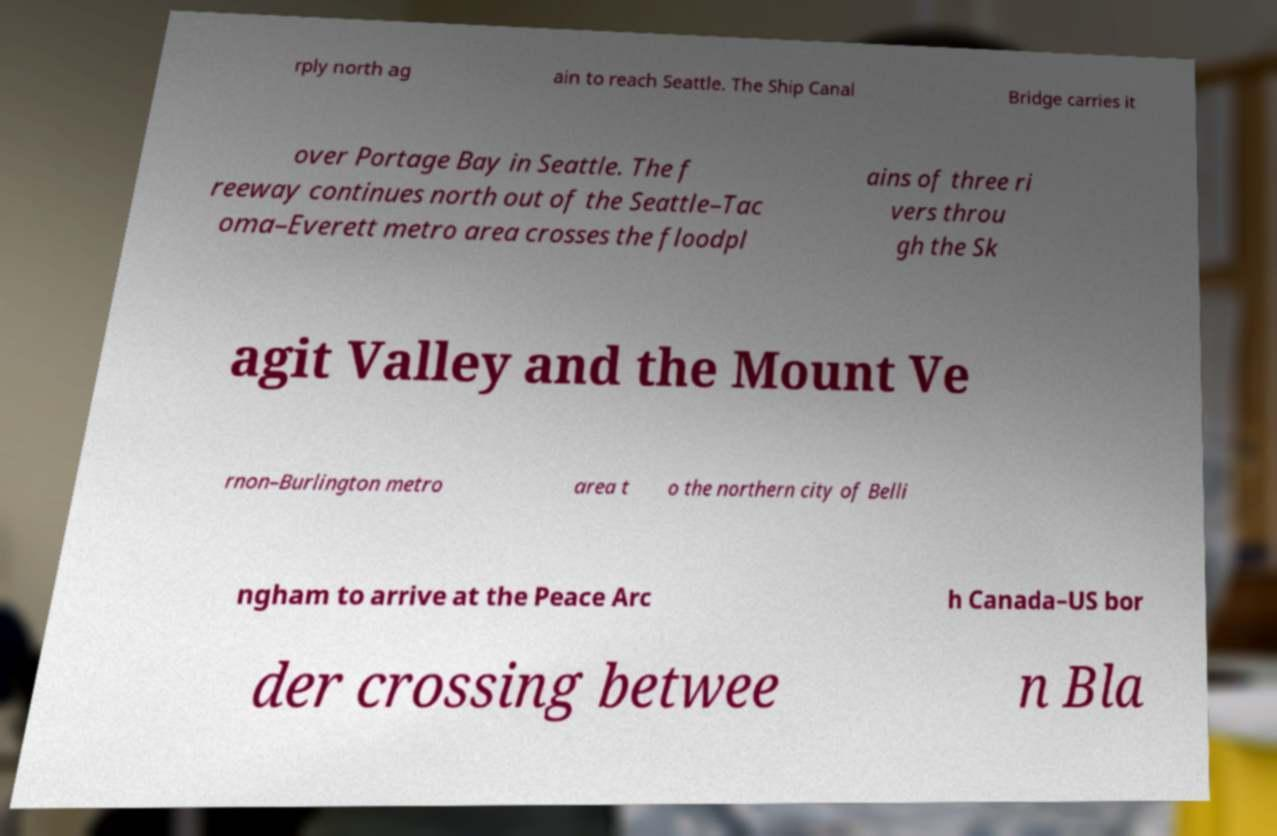What messages or text are displayed in this image? I need them in a readable, typed format. rply north ag ain to reach Seattle. The Ship Canal Bridge carries it over Portage Bay in Seattle. The f reeway continues north out of the Seattle–Tac oma–Everett metro area crosses the floodpl ains of three ri vers throu gh the Sk agit Valley and the Mount Ve rnon–Burlington metro area t o the northern city of Belli ngham to arrive at the Peace Arc h Canada–US bor der crossing betwee n Bla 